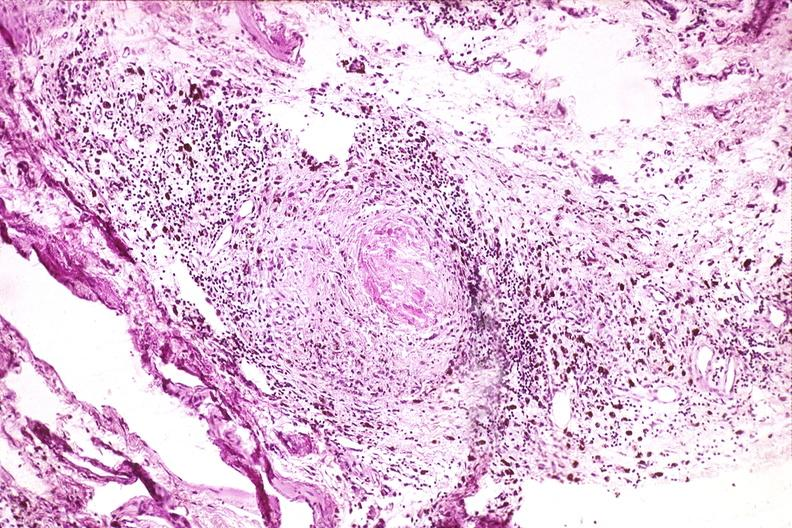s musculoskeletal present?
Answer the question using a single word or phrase. Yes 